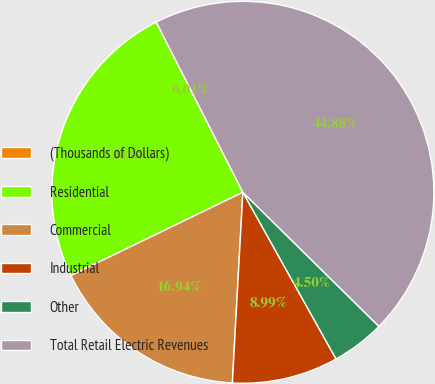Convert chart to OTSL. <chart><loc_0><loc_0><loc_500><loc_500><pie_chart><fcel>(Thousands of Dollars)<fcel>Residential<fcel>Commercial<fcel>Industrial<fcel>Other<fcel>Total Retail Electric Revenues<nl><fcel>0.01%<fcel>24.68%<fcel>16.94%<fcel>8.99%<fcel>4.5%<fcel>44.88%<nl></chart> 